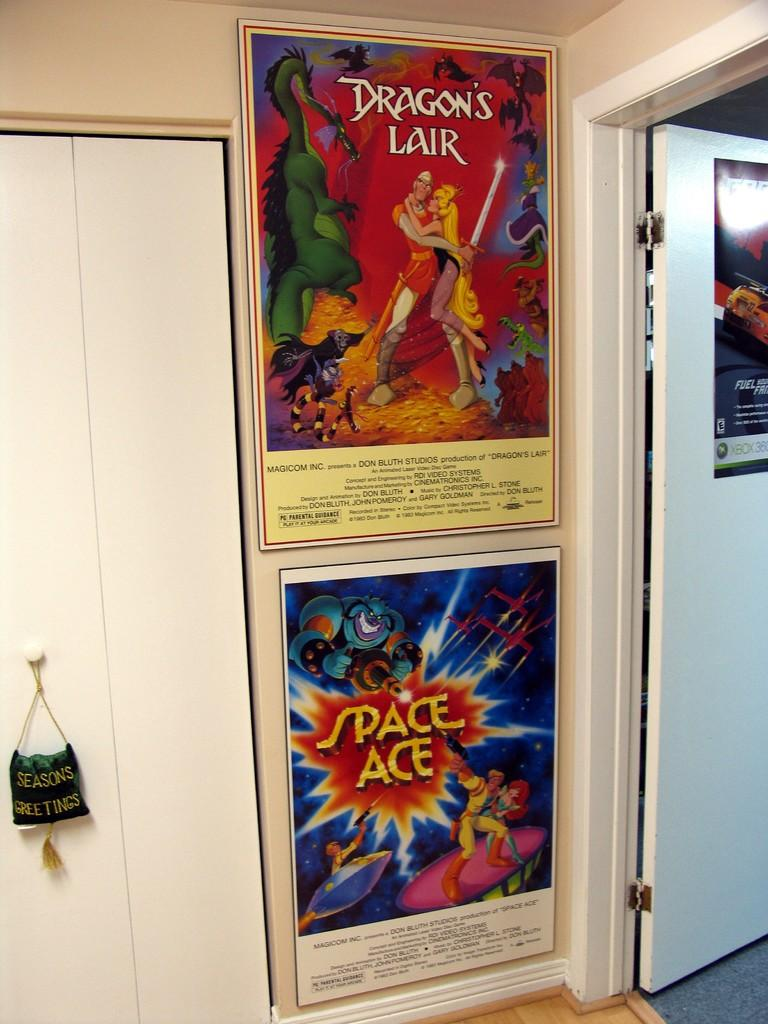Provide a one-sentence caption for the provided image. Two posters for Dragon's Lair and Space Ace hang on a white wall. 